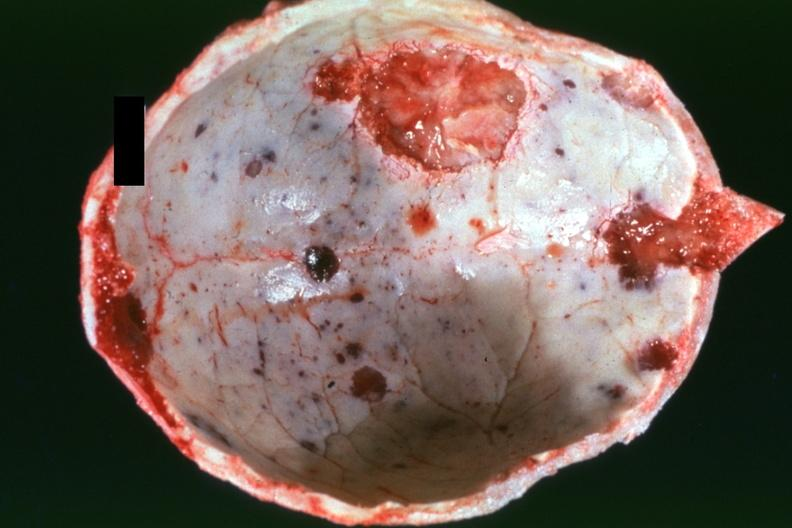does child show dr garcia tumors b5?
Answer the question using a single word or phrase. No 